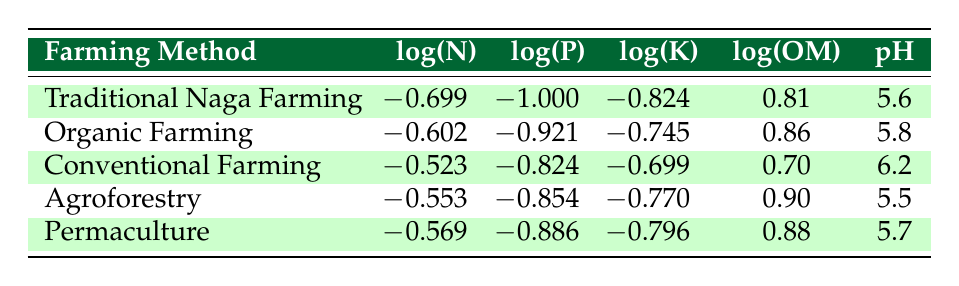What is the logarithmic value of Nitrogen for Organic Farming? The table shows the logarithmic value for Nitrogen in Organic Farming as -0.602.
Answer: -0.602 Which farming method has the highest organic matter level based on the table? By comparing the Organic Matter values in the table, Agroforestry has the highest level at 0.90.
Answer: Agroforestry What is the difference in the pH value between Conventional Farming and Traditional Naga Farming? The pH value for Conventional Farming is 6.2 while for Traditional Naga Farming it is 5.6. The difference is 6.2 - 5.6 = 0.6.
Answer: 0.6 Is the logarithmic value of phosphorus for Permaculture higher than that for Agroforestry? The logarithmic value of phosphorus for Permaculture is -0.886 and for Agroforestry, it is -0.854. Since -0.886 is lower than -0.854, the statement is false.
Answer: No What is the average logarithmic value of Potassium across all farming methods? First, sum the Potassium logarithmic values: (-0.824 + -0.745 + -0.699 + -0.770 + -0.796) = -3.834. There are 5 methods, so the average is -3.834/5 = -0.767.
Answer: -0.767 Which farming method has the lowest nitrogen level? By inspecting the table, Traditional Naga Farming has the lowest nitrogen level at 0.2, which corresponds to a logarithmic value of -0.699.
Answer: Traditional Naga Farming Is the pH value of Organic Farming greater than 5.5? The pH value for Organic Farming is 5.8, which is indeed greater than 5.5. Therefore, the statement is true.
Answer: Yes What is the sum of the logarithmic values of both Nitrogen and Potassium for Agroforestry? The logarithmic values for Agroforestry are -0.553 (Nitrogen) and -0.770 (Potassium). Adding these gives -0.553 + -0.770 = -1.323.
Answer: -1.323 